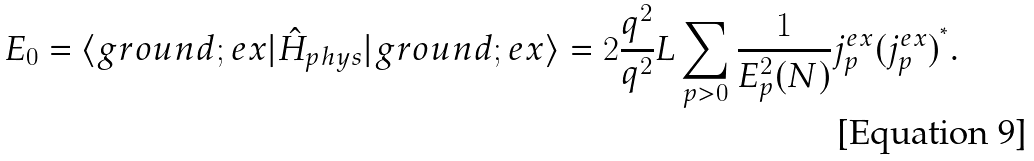Convert formula to latex. <formula><loc_0><loc_0><loc_500><loc_500>E _ { 0 } = \langle g r o u n d ; e x | \hat { H } _ { p h y s } | g r o u n d ; e x \rangle = { 2 } \frac { q ^ { 2 } } { q ^ { 2 } } L \sum _ { p > 0 } \frac { 1 } { E _ { p } ^ { 2 } ( N ) } j _ { p } ^ { e x } ( j _ { p } ^ { e x } ) ^ { ^ { * } } .</formula> 